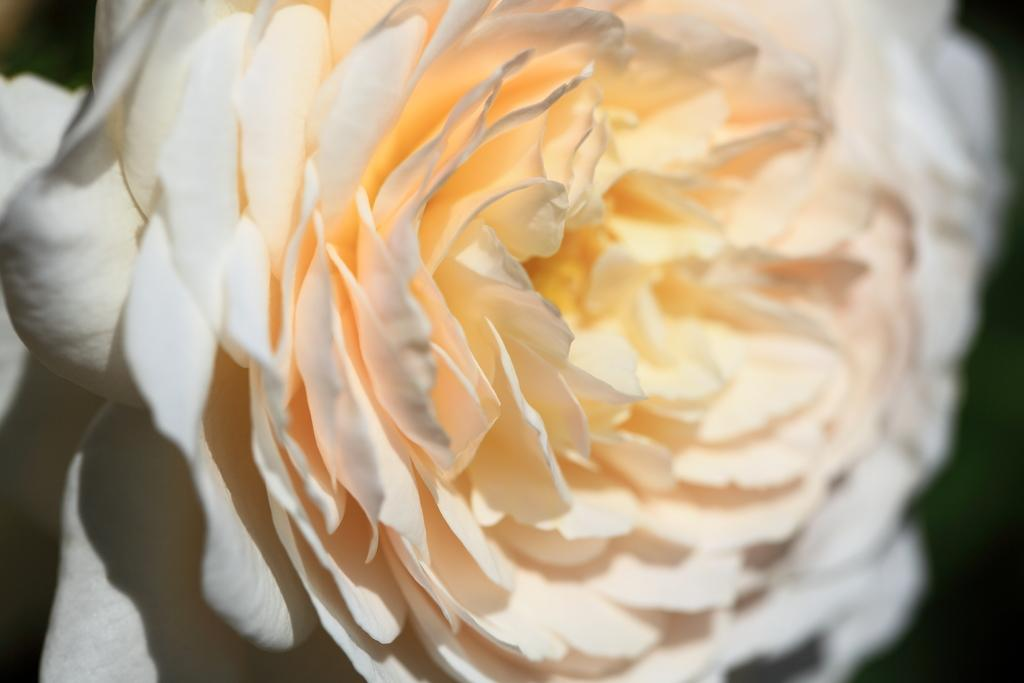What type of flower is present in the image? There is a white color flower in the image. What is the color of the background in the image? The background of the image is black. How many tomatoes can be seen growing on the map in the image? There is no map or tomatoes present in the image. What type of ducks can be seen swimming in the flower in the image? There are no ducks present in the image, and the flower is not a body of water for ducks to swim in. 